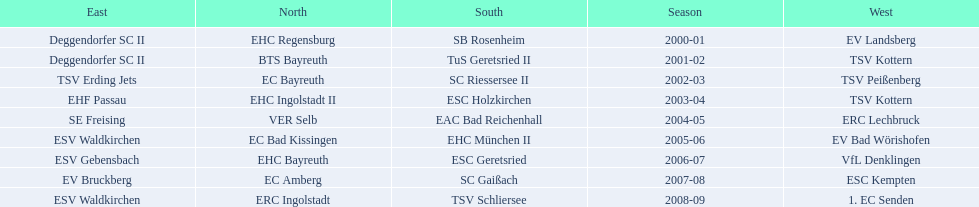Who won the season in the north before ec bayreuth did in 2002-03? BTS Bayreuth. 